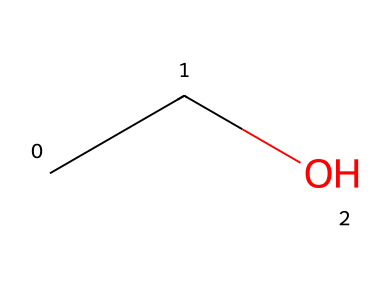What is the name of this chemical? The SMILES representation "CCO" corresponds to ethanol, which is the common name for this compound.
Answer: ethanol How many carbon atoms are present in this molecule? The SMILES "CCO" shows two 'C' which indicates there are two carbon atoms in the structure.
Answer: 2 What type of functional group does this chemical contain? Ethanol contains a hydroxyl (-OH) group, as seen in the “O” part of the SMILES, designating it as an alcohol.
Answer: alcohol What is the total number of hydrogen atoms in this molecule? Each carbon in ethanol is bonded to enough hydrogen atoms to satisfy carbon’s tetravalent nature. The structure has six hydrogen atoms in total (C2H6O).
Answer: 6 Does this compound contain any double bonds? The SMILES representation does not indicate any double bonds between the carbon or oxygen atoms; both carbons are single-bonded to each other and to other atoms.
Answer: no What would be the effect of the hydroxyl group on the properties of this chemical? The presence of the hydroxyl group makes ethanol polar and increases its solubility in water, affecting its interaction with other solvents and compounds.
Answer: increases solubility What is a common use of this chemical in cosmetic products? Ethanol is frequently used in cosmetics as a solvent and antimicrobial agent, contributing to the stability and effectiveness of various formulations.
Answer: solvent 